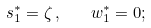Convert formula to latex. <formula><loc_0><loc_0><loc_500><loc_500>s _ { 1 } ^ { * } = \zeta \, , \quad w _ { 1 } ^ { * } = 0 ;</formula> 